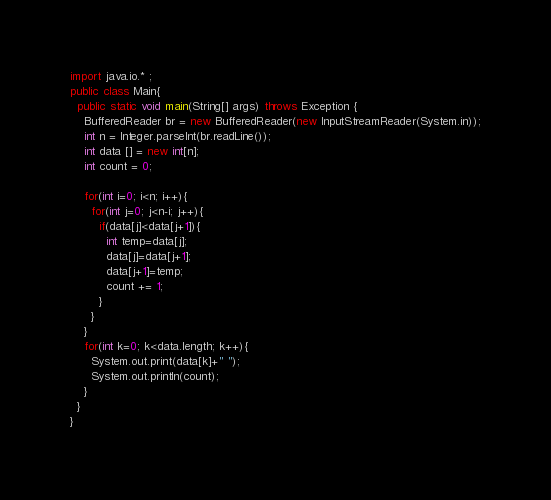Convert code to text. <code><loc_0><loc_0><loc_500><loc_500><_Java_>import java.io.* ;
public class Main{
  public static void main(String[] args) throws Exception {
    BufferedReader br = new BufferedReader(new InputStreamReader(System.in));
    int n = Integer.parseInt(br.readLine());
    int data [] = new int[n];
    int count = 0;

    for(int i=0; i<n; i++){
      for(int j=0; j<n-i; j++){
        if(data[j]<data[j+1]){
          int temp=data[j];
          data[j]=data[j+1];
          data[j+1]=temp;
          count += 1;
        }
      }
    }
    for(int k=0; k<data.length; k++){
      System.out.print(data[k]+" ");
      System.out.println(count);
    }
  }
}</code> 